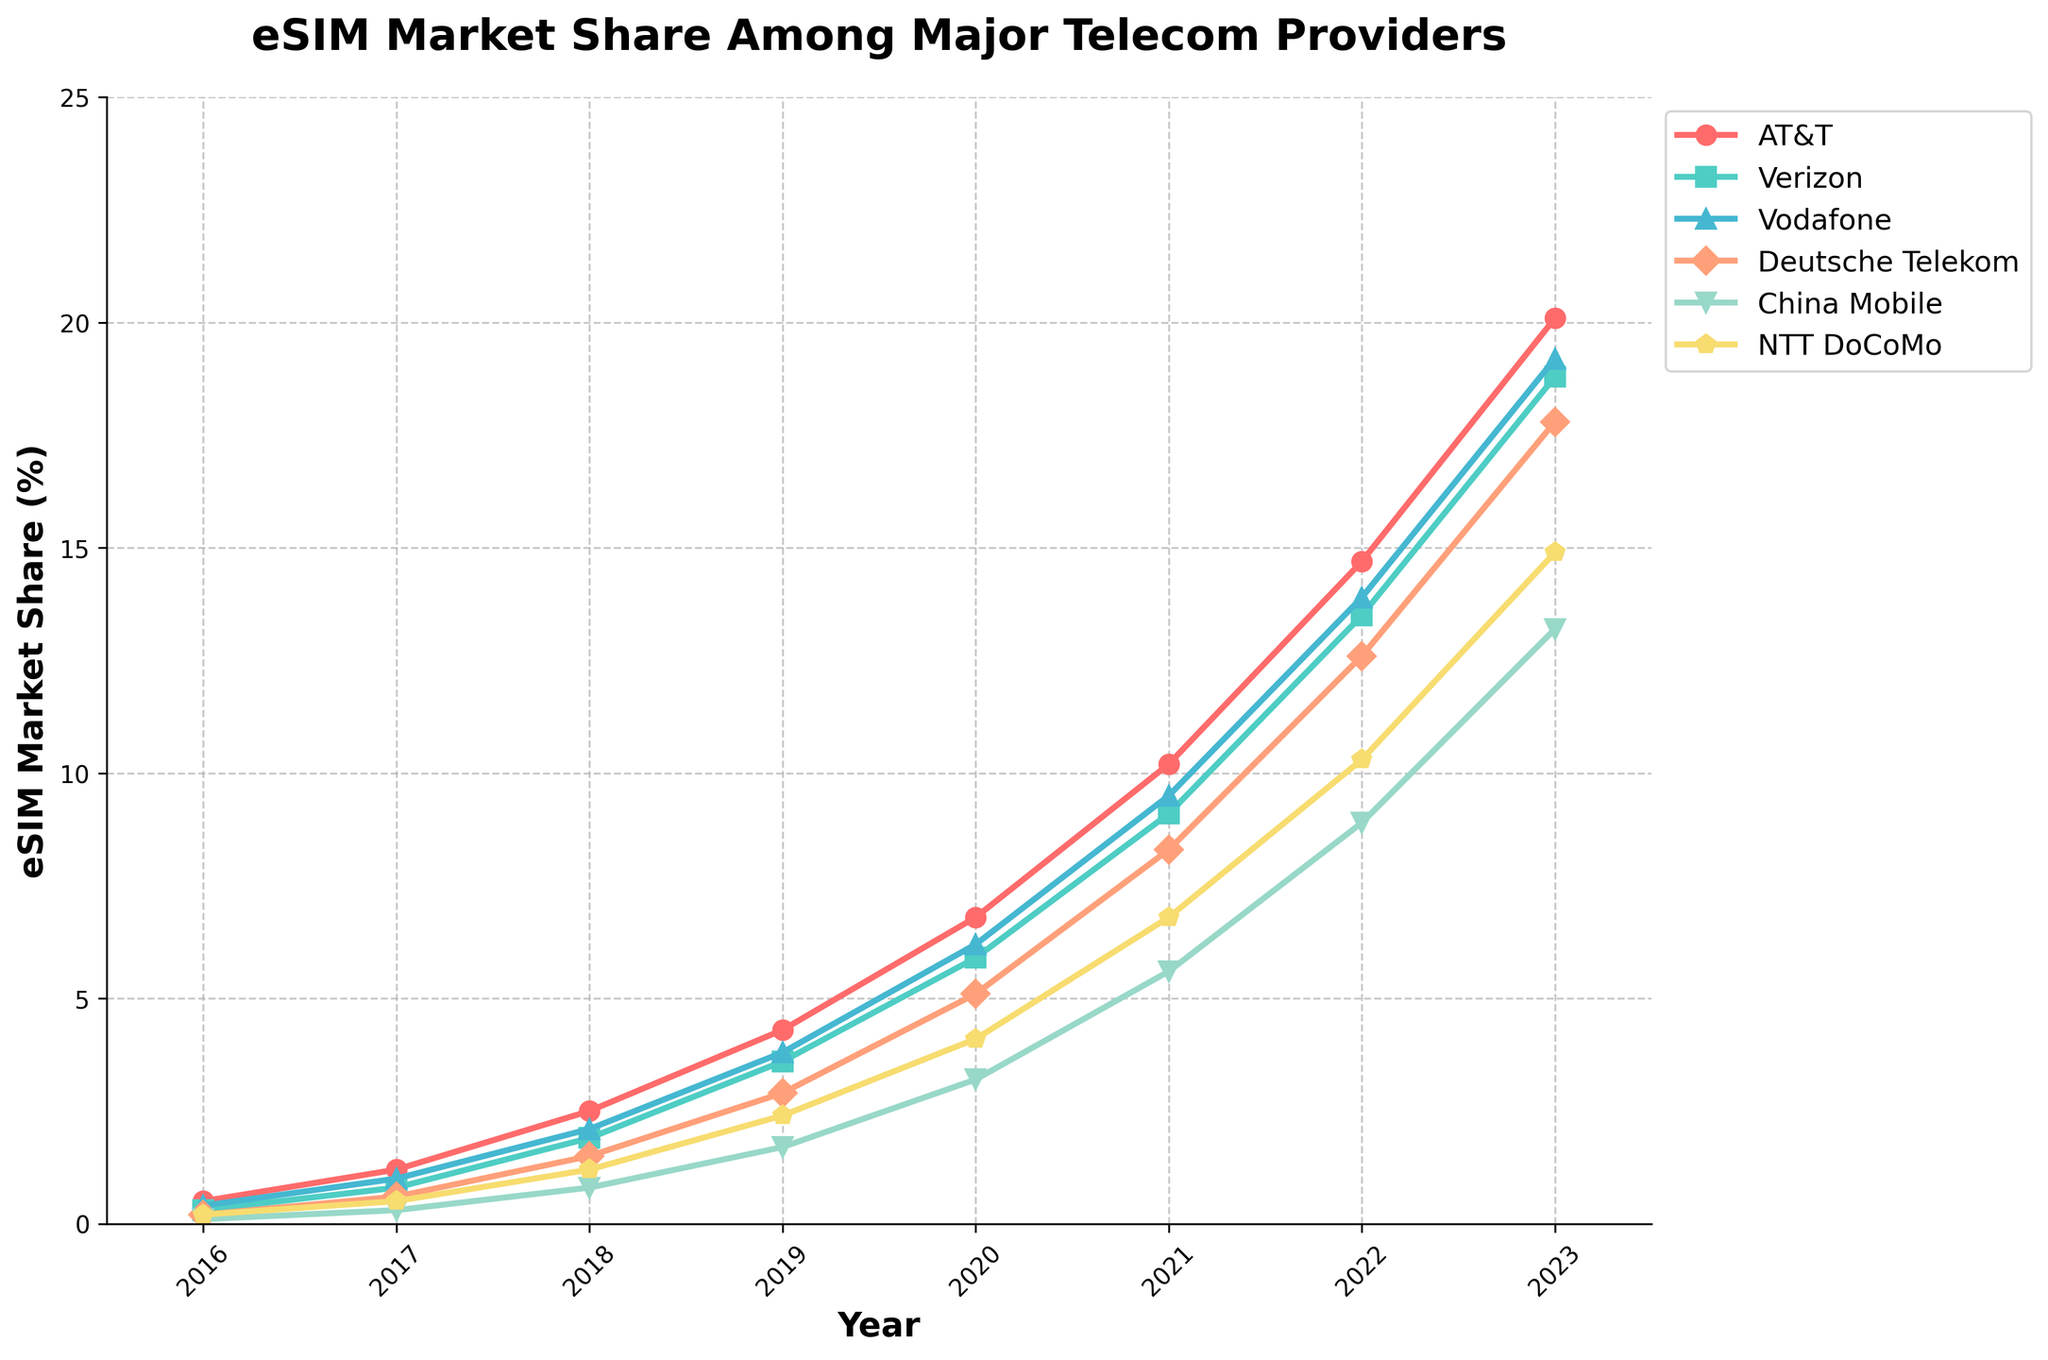How did the market share of AT&T change from 2016 to 2021? To determine the change, find the values for AT&T in 2016 and 2021 and calculate the difference. The market share in 2016 was 0.5% and 10.2% in 2021. The change is 10.2 - 0.5 = 9.7%
Answer: Increased by 9.7% Which telecom provider had the highest market share in 2023? Identify the highest data point in 2023 for all providers. The highest value in 2023 is 20.1%, which belongs to AT&T
Answer: AT&T What is the average market share of Vodafone from 2019 to 2023? List the market shares for Vodafone from 2019 to 2023: 2019 (3.8%), 2020 (6.2%), 2021 (9.5%), 2022 (13.9%), 2023 (19.2%), and calculate the average: (3.8 + 6.2 + 9.5 + 13.9 + 19.2) / 5 = 10.52%
Answer: 10.52% Which telecom provider showed the greatest increase in market share between 2017 and 2019? Calculate the increase for each provider from 2017 to 2019: AT&T (4.3-1.2=3.1), Verizon (3.6-0.8=2.8), Vodafone (3.8-1=2.8), Deutsche Telekom (2.9-0.6=2.3), China Mobile (1.7-0.3=1.4), NTT DoCoMo (2.4-0.5=1.9). The greatest increase is from AT&T
Answer: AT&T Was there any year where Deutsche Telekom's market share was exactly equal to China Mobile's? Compare the yearly values of Deutsche Telekom and China Mobile: 2016 (0.2 and 0.1), 2017 (0.6 and 0.3), 2018 (1.5 and 0.8), 2019 (2.9 and 1.7), 2020 (5.1 and 3.2), 2021 (8.3 and 5.6), 2022 (12.6 and 8.9), 2023 (17.8 and 13.2). No years match exactly
Answer: No In which year did NTT DoCoMo overtake Vodafone in market share? Compare NTT DoCoMo's and Vodafone's market shares each year. The market shares are: 2016 (0.2 < 0.4), 2017 (0.5 < 1.0), 2018 (1.2 < 2.1), 2019 (2.4 < 3.8), 2020 (4.1 < 6.2), but 2020 onwards, NTT DoCoMo never overtakes Vodafone. Thus, no year exists
Answer: Never What is the combined market share of AT&T and Verizon in 2023? Add the market shares of AT&T and Verizon in 2023, which are 20.1% and 18.8% respectively: 20.1 + 18.8 = 38.9%
Answer: 38.9% Which two telecom providers had the most similar market share in 2020? Calculate the absolute differences in market share among all providers in 2020 and find the smallest difference: AT&T and Verizon (0.9 difference)
Answer: AT&T and Verizon By how much did China Mobile's market share grow from 2016 to 2023? Find the market shares of China Mobile in 2016 and 2023: 0.1% and 13.2%, respectively. Calculate the increase: 13.2 - 0.1 = 13.1%
Answer: 13.1% What was the trend in market share for Deutsche Telekom from 2017 to 2023? Examine Deutsche Telekom's market shares over the years 2017 (0.6%), 2018 (1.5%), 2019 (2.9%), 2020 (5.1%), 2021 (8.3%), 2022 (12.6%), 2023 (17.8%). The values show a consistent increase
Answer: Consistently increasing 